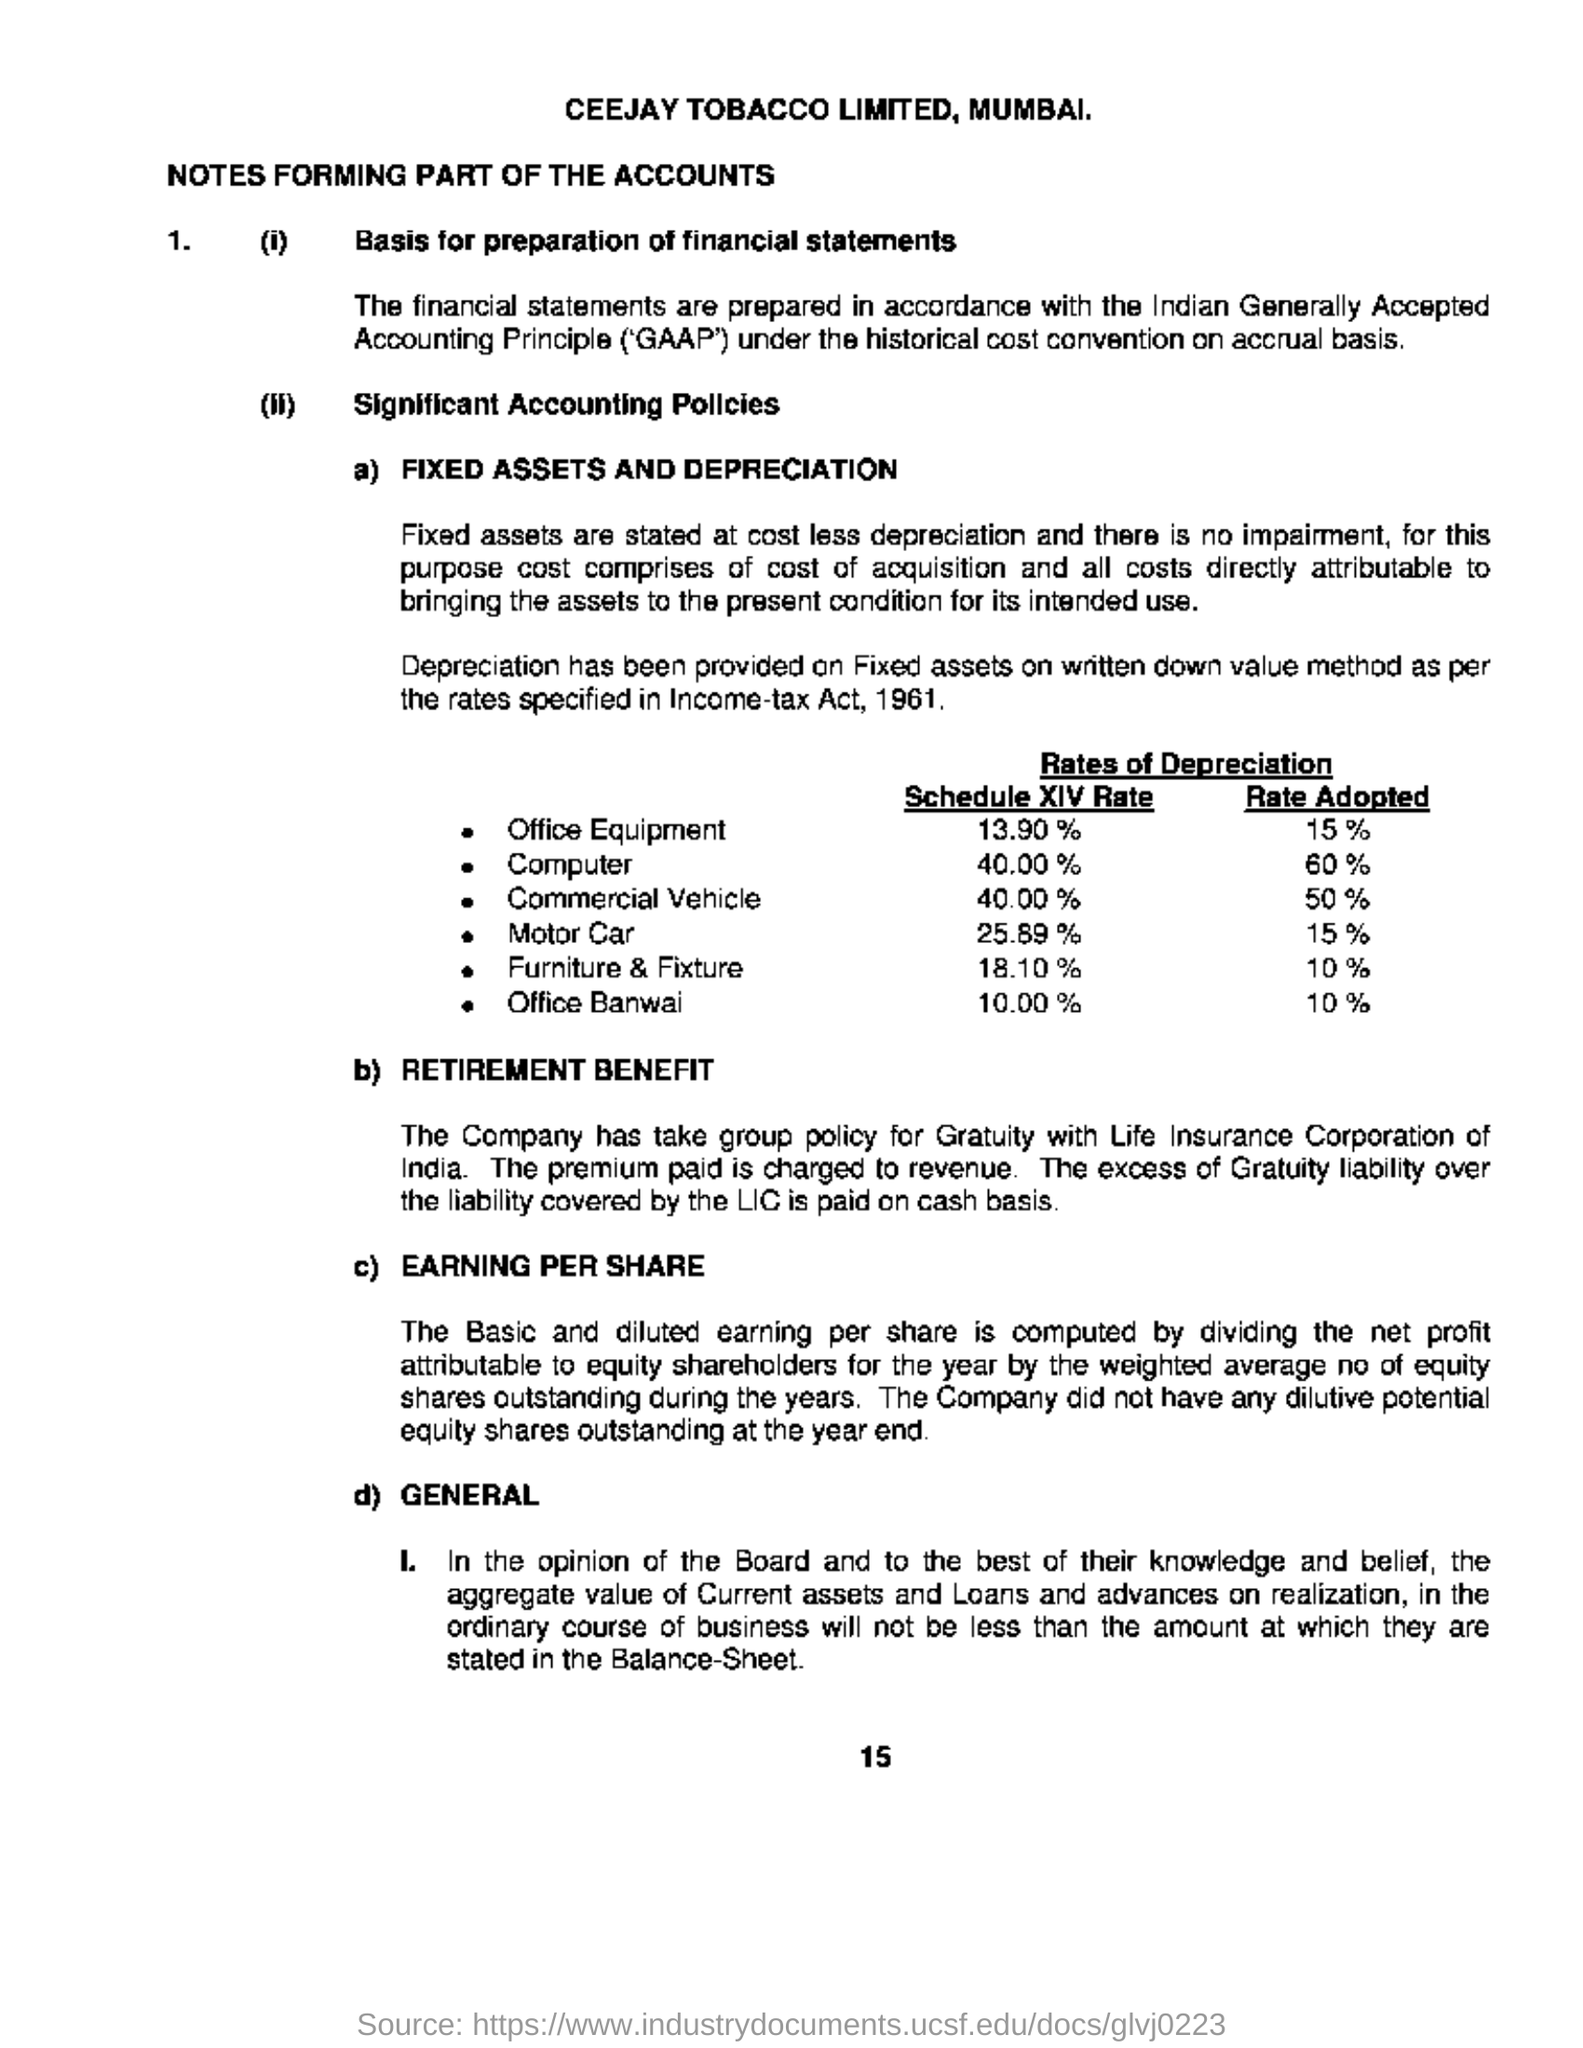Mention a couple of crucial points in this snapshot. Ceejay Tobacco Limited is the company name. The rate for office equipment is 15%. The company has taken a group policy for gratuity with the Life Insurance Corporation of India. Ceejay Tobacco Limited is located in Mumbai. The Income Tax Act was introduced in 1961. 